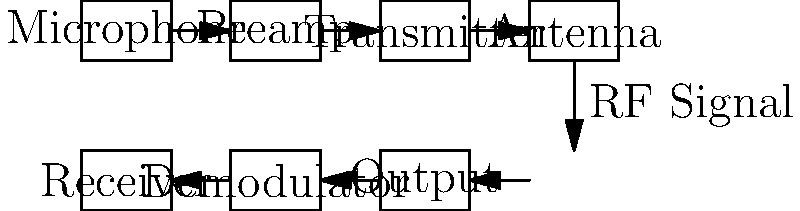In the context of documentary filmmaking, design a block diagram for a wireless microphone system. Which component would you modify to enhance the system's ability to capture clear audio in challenging outdoor environments with varying background noise levels? To answer this question, let's analyze the components of the wireless microphone system:

1. Microphone: Converts sound waves into electrical signals.
2. Preamp: Amplifies the weak microphone signal.
3. Transmitter: Modulates the audio signal for wireless transmission.
4. Antenna (Transmitter): Radiates the RF signal.
5. Antenna (Receiver): Captures the RF signal.
6. Receiver: Picks up the transmitted signal.
7. Demodulator: Extracts the audio signal from the RF carrier.
8. Output: Provides the recovered audio signal.

In challenging outdoor environments with varying background noise levels, the most critical component to modify would be the microphone itself. Here's why:

1. The microphone is the first point of audio capture, and its characteristics greatly influence the overall sound quality.
2. Outdoor environments often have unpredictable and varying noise levels, which can interfere with the desired audio.
3. By modifying the microphone, we can implement noise-reduction techniques at the source, before the signal goes through the rest of the system.

Possible modifications to the microphone could include:
- Using a directional microphone (e.g., shotgun microphone) to focus on the subject and reject off-axis noise.
- Implementing active noise cancellation technology in the microphone itself.
- Utilizing a windscreen or blimp to reduce wind noise, which is common in outdoor settings.
- Incorporating adaptive filtering techniques to adjust to changing noise conditions.

By enhancing the microphone's ability to capture clear audio in challenging environments, we improve the overall quality of the audio throughout the entire system, making post-production work easier and potentially reducing the need for extensive audio cleanup in the editing process.
Answer: Microphone 